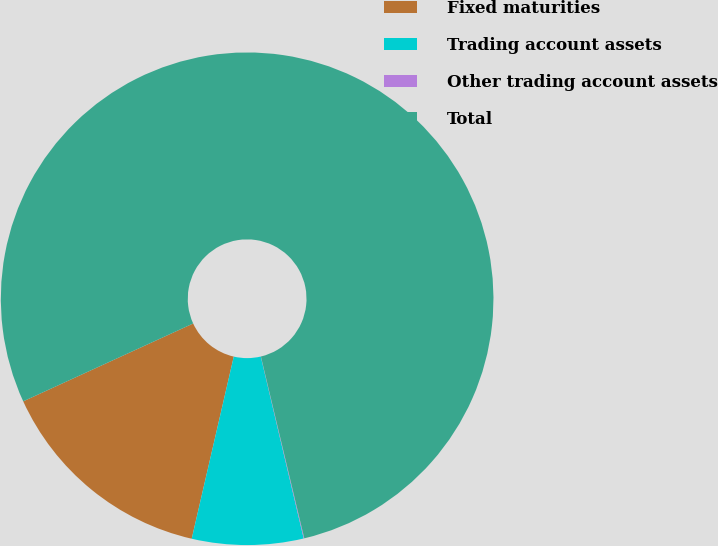<chart> <loc_0><loc_0><loc_500><loc_500><pie_chart><fcel>Fixed maturities<fcel>Trading account assets<fcel>Other trading account assets<fcel>Total<nl><fcel>14.55%<fcel>7.3%<fcel>0.04%<fcel>78.11%<nl></chart> 